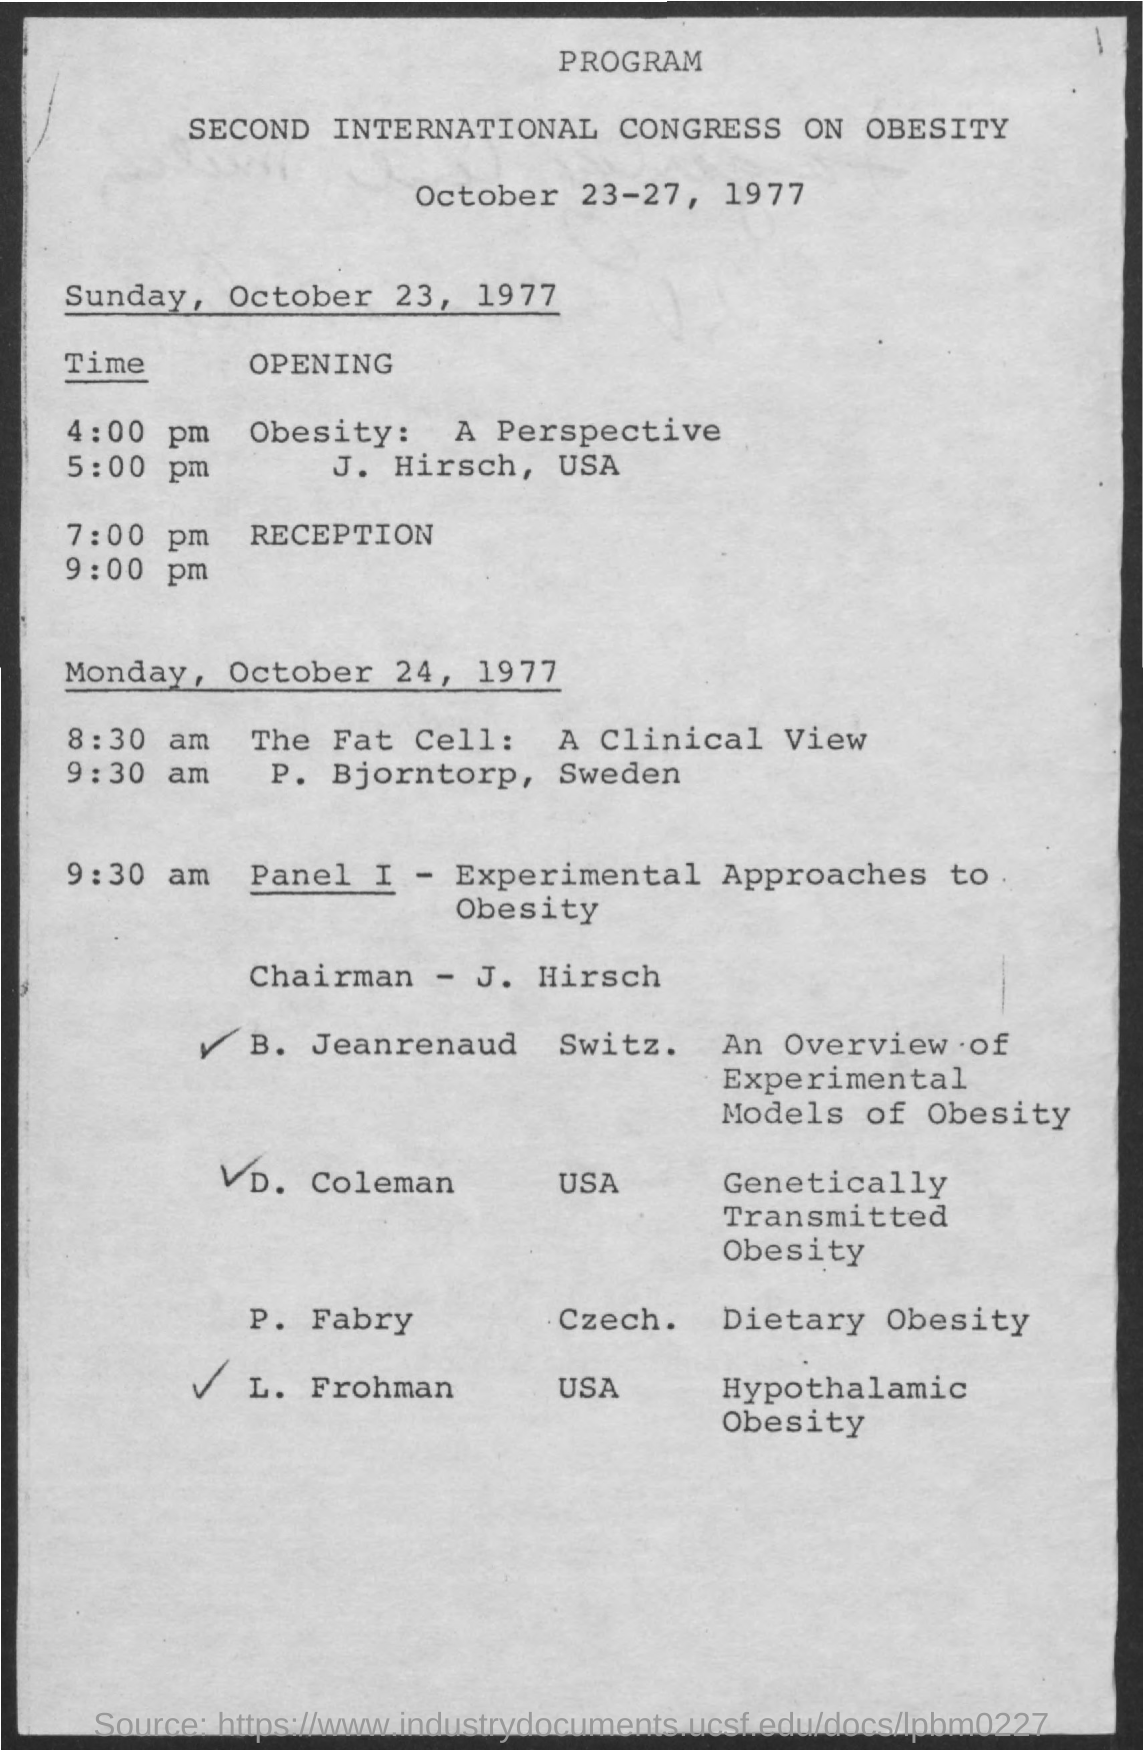October 23, 1977 is on which day
Offer a terse response. Sunday. Who is the chairman ?
Your answer should be compact. J Hirsch. What is this program about?
Provide a succinct answer. Second international congress on obesity. October 24 , 1977 is on which day ?
Ensure brevity in your answer.  Monday. 